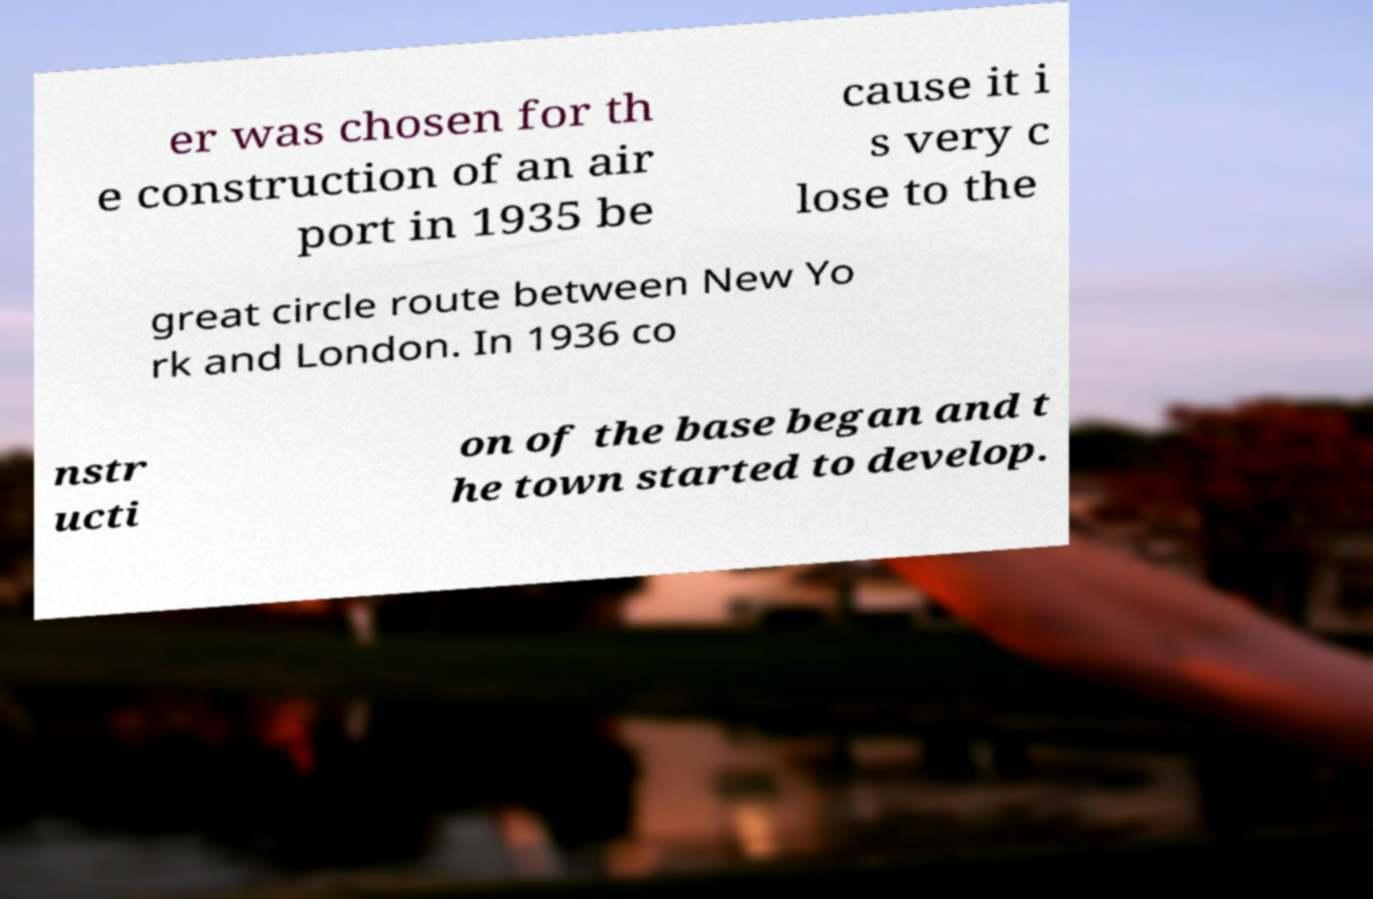Please identify and transcribe the text found in this image. er was chosen for th e construction of an air port in 1935 be cause it i s very c lose to the great circle route between New Yo rk and London. In 1936 co nstr ucti on of the base began and t he town started to develop. 